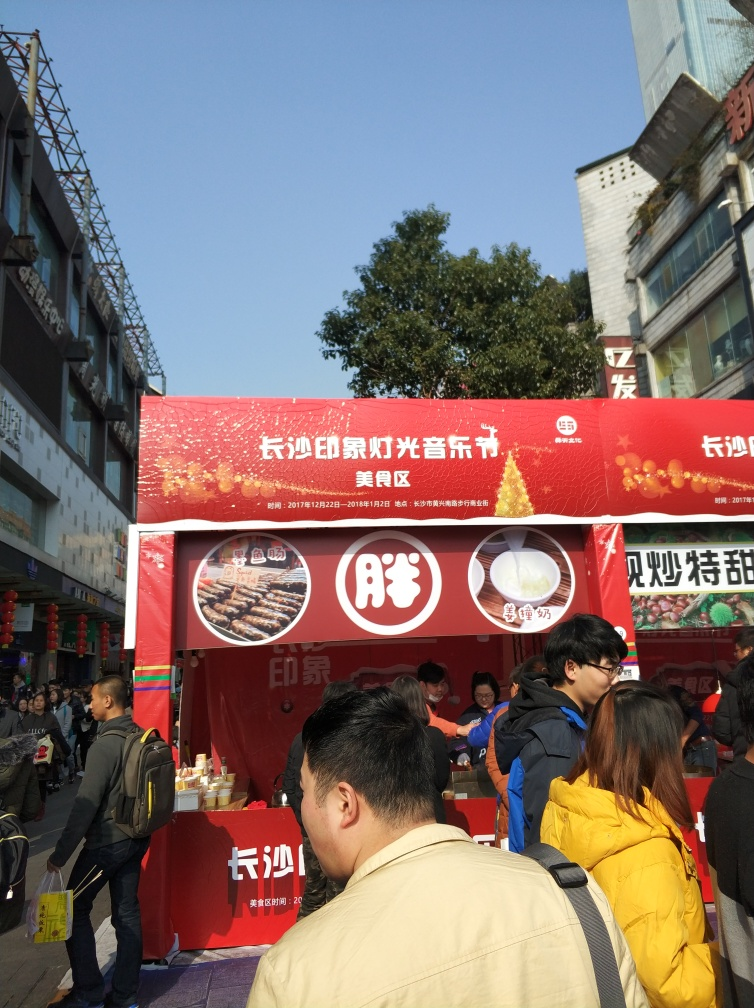Can you tell me what kind of food the stall is selling? The stall in the image appears to be selling skewered food items, possibly grilled meats, as suggested by the pictures on the red banner. 